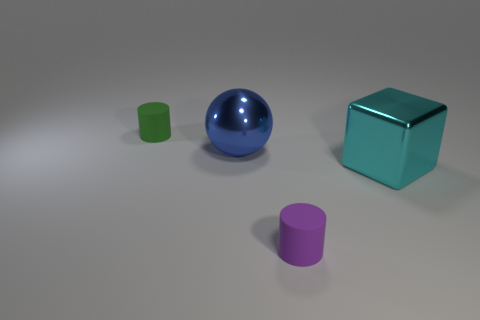What number of objects are either large cyan metallic things or cylinders on the left side of the large metallic block?
Make the answer very short. 3. The thing that is to the right of the blue thing and on the left side of the big cyan object is what color?
Your answer should be compact. Purple. Is the purple thing the same size as the blue thing?
Ensure brevity in your answer.  No. There is a matte thing in front of the blue object; what color is it?
Ensure brevity in your answer.  Purple. There is another cylinder that is the same size as the purple matte cylinder; what is its color?
Your response must be concise. Green. Do the large blue object and the green rubber object have the same shape?
Keep it short and to the point. No. What material is the cylinder behind the big cyan metal thing?
Provide a succinct answer. Rubber. The large metal sphere is what color?
Your response must be concise. Blue. There is a matte object in front of the tiny green matte cylinder; does it have the same size as the cylinder that is behind the big metal sphere?
Make the answer very short. Yes. There is a thing that is in front of the small green cylinder and behind the large cyan cube; how big is it?
Offer a terse response. Large. 